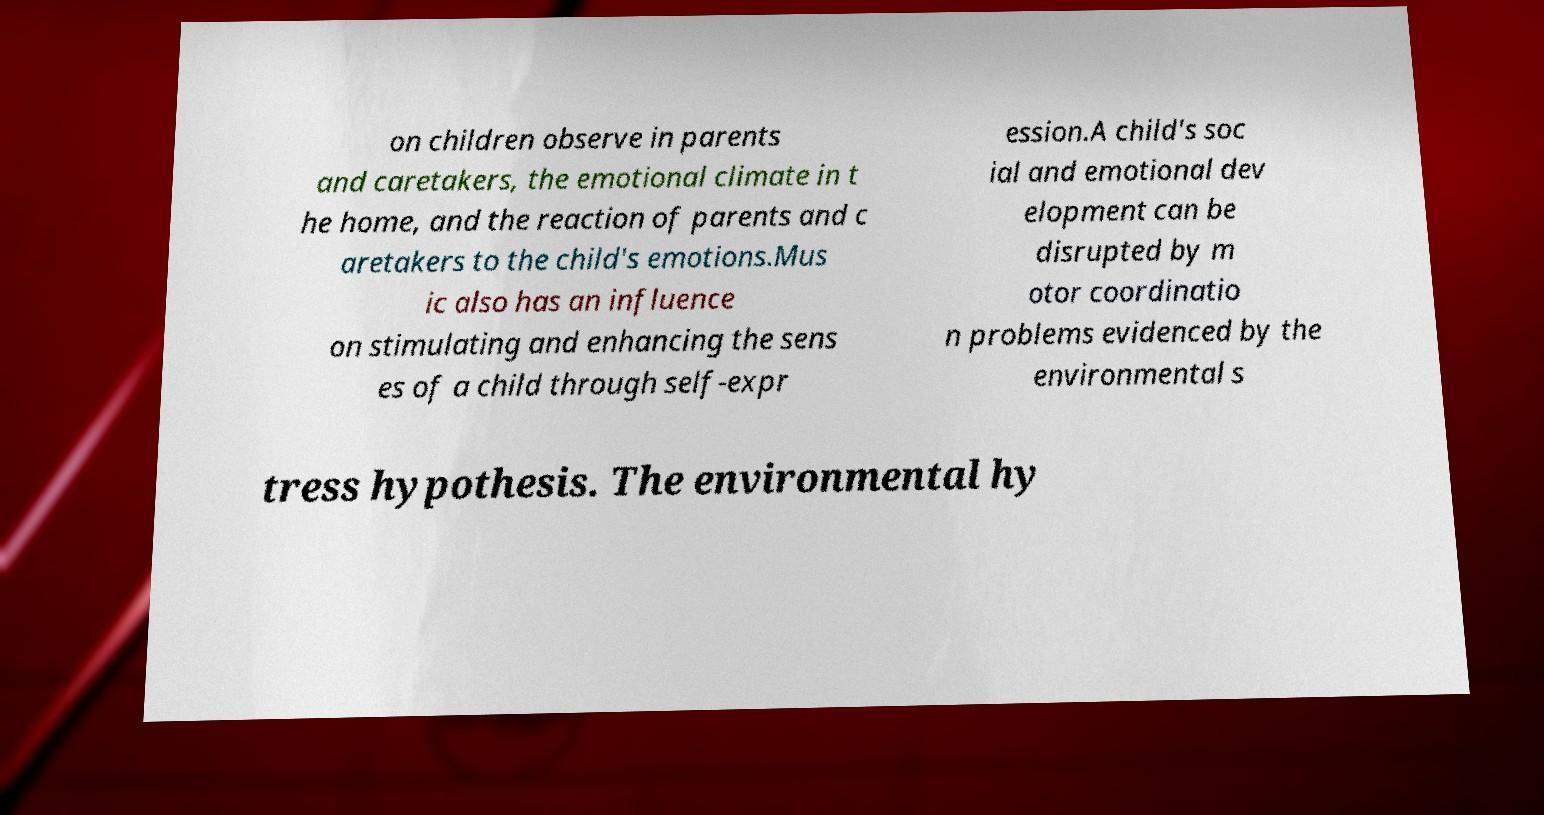I need the written content from this picture converted into text. Can you do that? on children observe in parents and caretakers, the emotional climate in t he home, and the reaction of parents and c aretakers to the child's emotions.Mus ic also has an influence on stimulating and enhancing the sens es of a child through self-expr ession.A child's soc ial and emotional dev elopment can be disrupted by m otor coordinatio n problems evidenced by the environmental s tress hypothesis. The environmental hy 